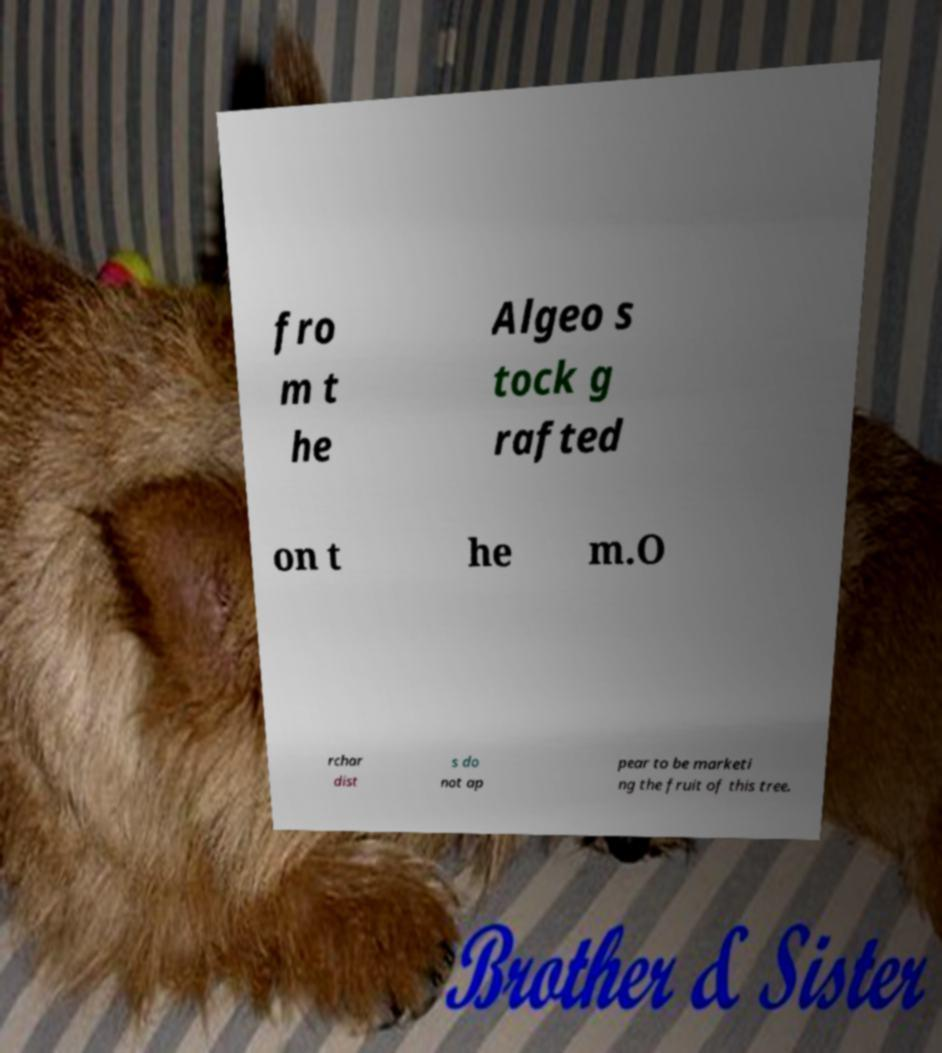Could you assist in decoding the text presented in this image and type it out clearly? fro m t he Algeo s tock g rafted on t he m.O rchar dist s do not ap pear to be marketi ng the fruit of this tree. 